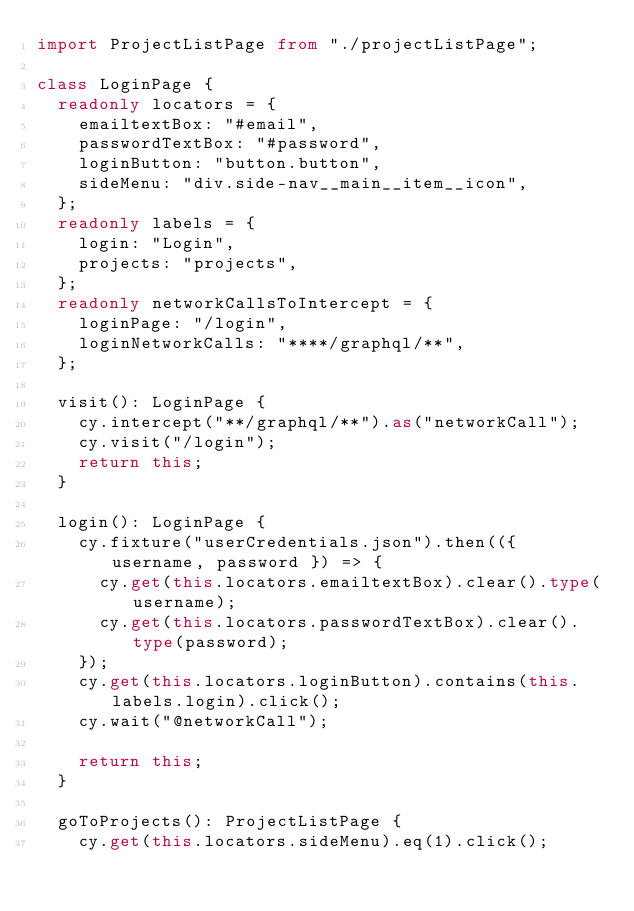Convert code to text. <code><loc_0><loc_0><loc_500><loc_500><_TypeScript_>import ProjectListPage from "./projectListPage";

class LoginPage {
  readonly locators = {
    emailtextBox: "#email",
    passwordTextBox: "#password",
    loginButton: "button.button",
    sideMenu: "div.side-nav__main__item__icon",
  };
  readonly labels = {
    login: "Login",
    projects: "projects",
  };
  readonly networkCallsToIntercept = {
    loginPage: "/login",
    loginNetworkCalls: "****/graphql/**",
  };

  visit(): LoginPage {
    cy.intercept("**/graphql/**").as("networkCall");
    cy.visit("/login");
    return this;
  }

  login(): LoginPage {
    cy.fixture("userCredentials.json").then(({ username, password }) => {
      cy.get(this.locators.emailtextBox).clear().type(username);
      cy.get(this.locators.passwordTextBox).clear().type(password);
    });
    cy.get(this.locators.loginButton).contains(this.labels.login).click();
    cy.wait("@networkCall");

    return this;
  }

  goToProjects(): ProjectListPage {
    cy.get(this.locators.sideMenu).eq(1).click();</code> 